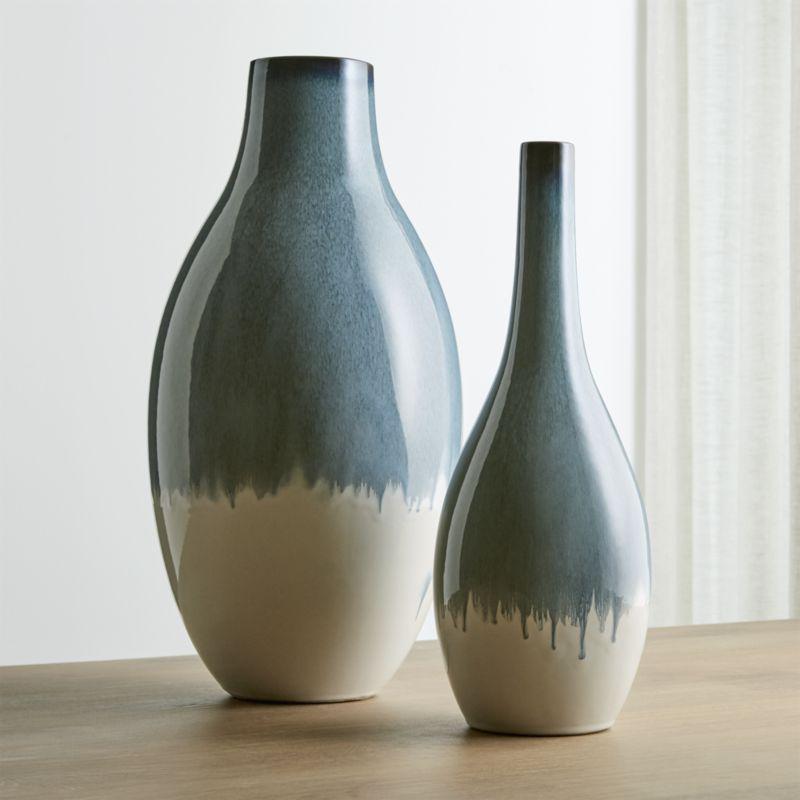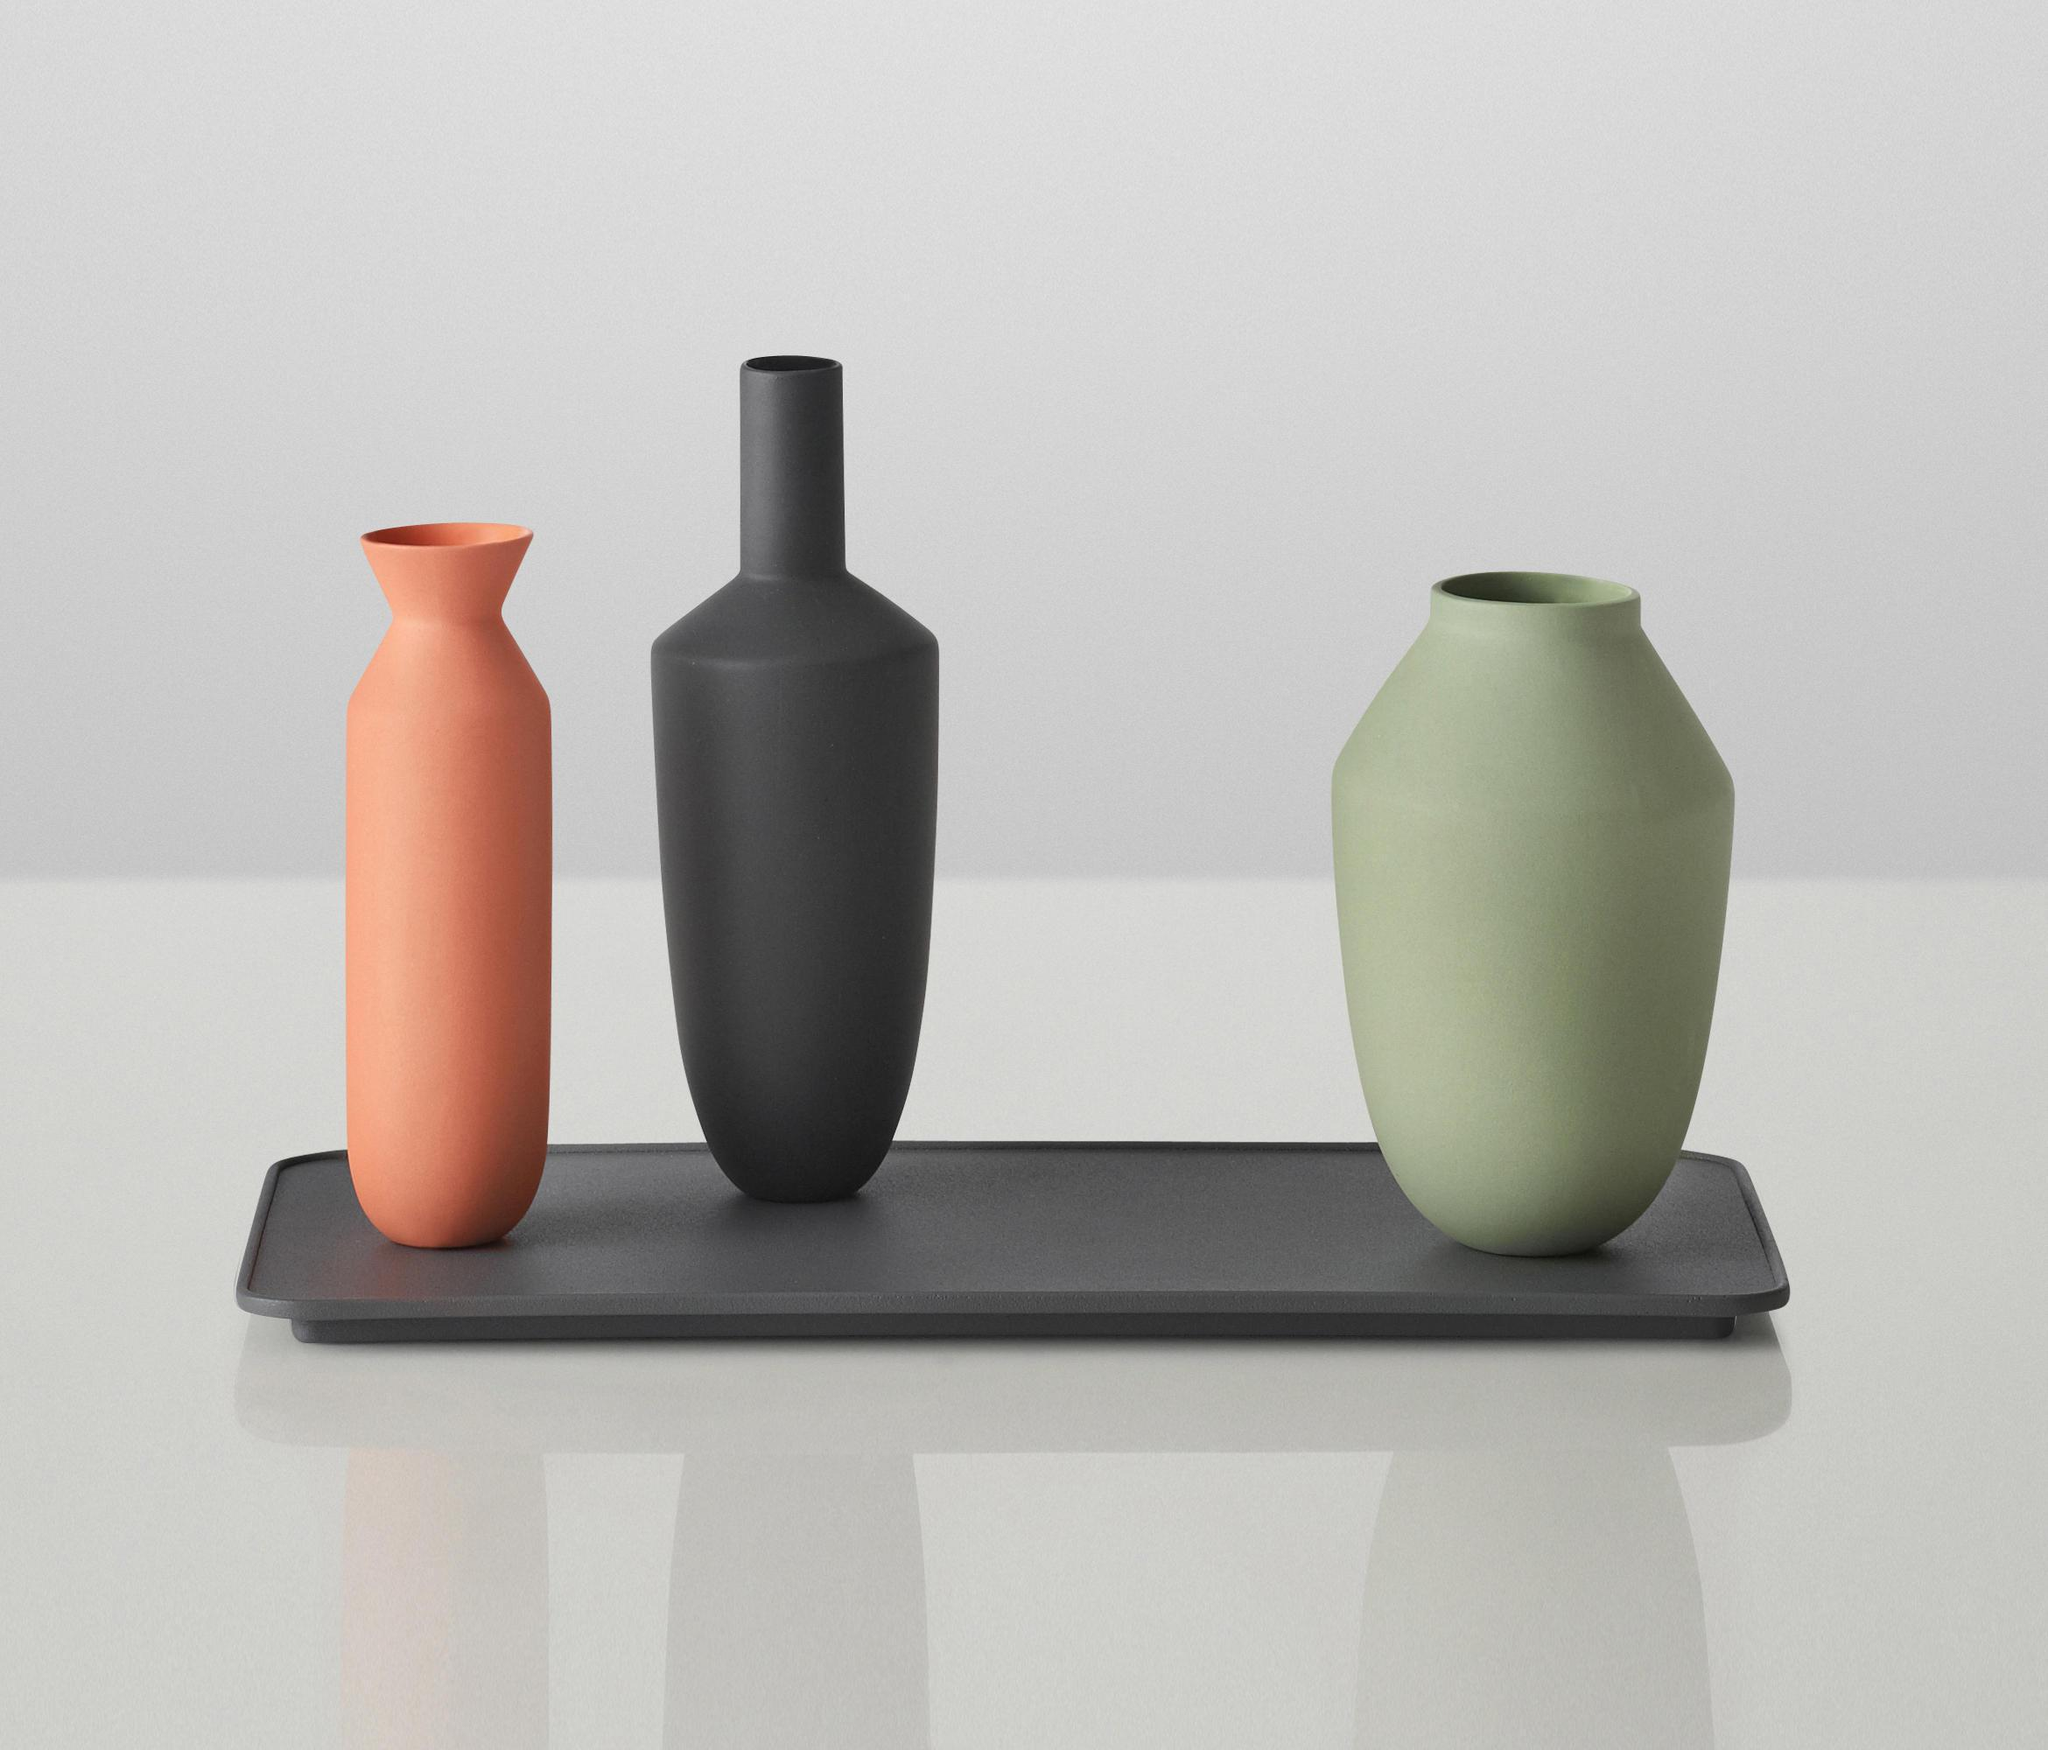The first image is the image on the left, the second image is the image on the right. Considering the images on both sides, is "Bottles in the left image share the same shape." valid? Answer yes or no. No. The first image is the image on the left, the second image is the image on the right. Analyze the images presented: Is the assertion "There is at least two vases in one of the images that are blue and white." valid? Answer yes or no. Yes. 